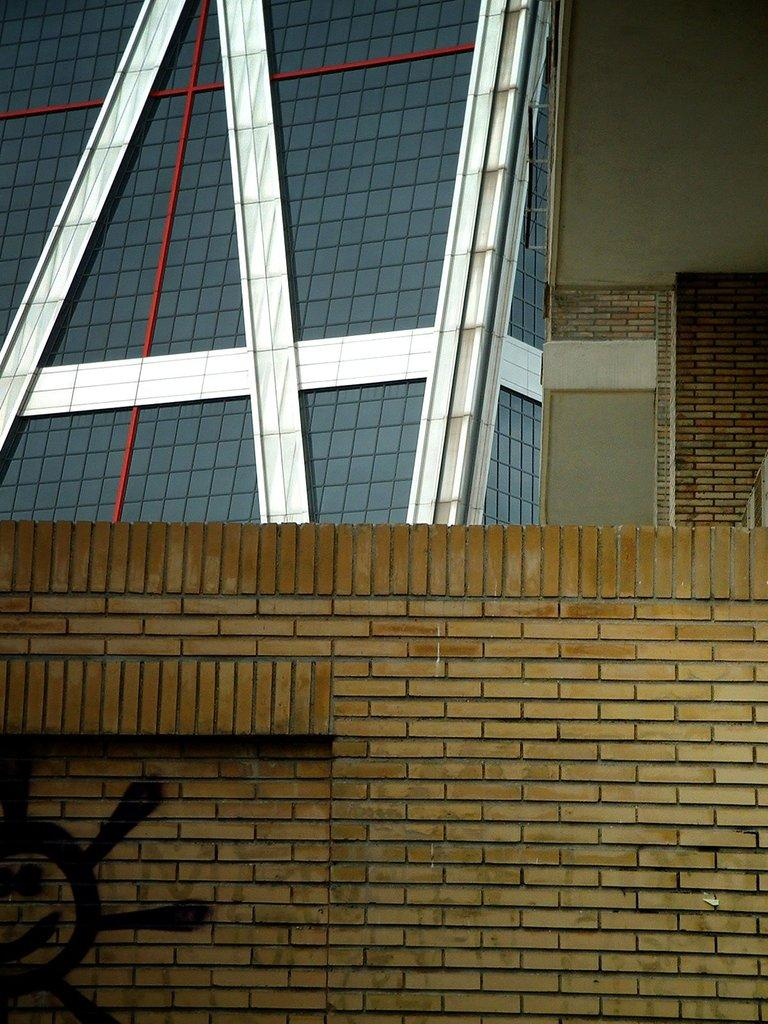What is the main feature of the image? There is a wall in the image. Can you see any trails made by beads or berries on the wall in the image? There is no mention of trails, beads, or berries in the image, and therefore no such features can be observed. 